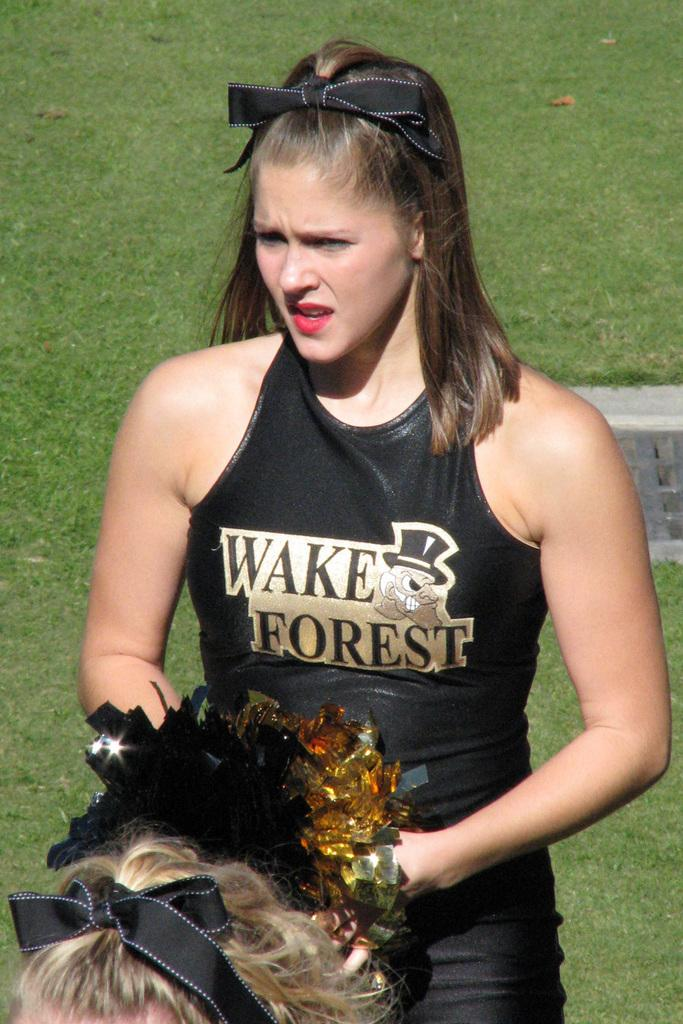<image>
Offer a succinct explanation of the picture presented. A cheerleader is wearing a black shirt that says Wake Forest. 